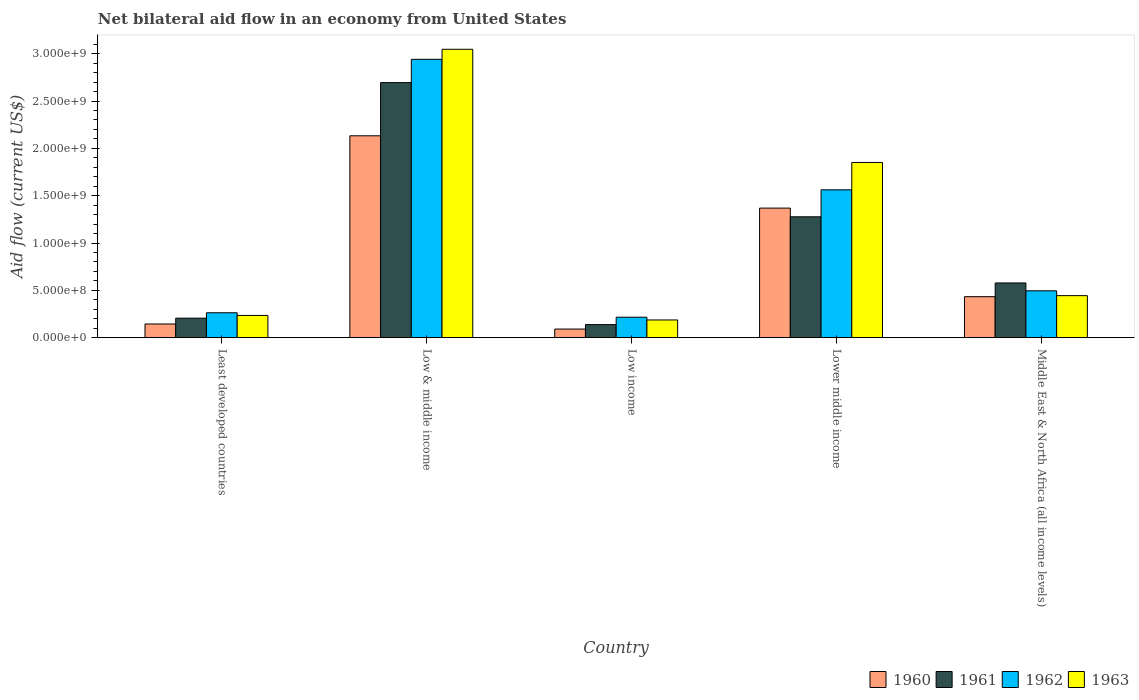How many different coloured bars are there?
Make the answer very short. 4. How many groups of bars are there?
Your answer should be very brief. 5. Are the number of bars per tick equal to the number of legend labels?
Your response must be concise. Yes. Are the number of bars on each tick of the X-axis equal?
Your answer should be very brief. Yes. How many bars are there on the 1st tick from the left?
Your answer should be compact. 4. How many bars are there on the 5th tick from the right?
Offer a terse response. 4. In how many cases, is the number of bars for a given country not equal to the number of legend labels?
Your answer should be compact. 0. What is the net bilateral aid flow in 1962 in Low & middle income?
Your response must be concise. 2.94e+09. Across all countries, what is the maximum net bilateral aid flow in 1960?
Provide a short and direct response. 2.13e+09. Across all countries, what is the minimum net bilateral aid flow in 1960?
Provide a succinct answer. 9.10e+07. In which country was the net bilateral aid flow in 1961 maximum?
Give a very brief answer. Low & middle income. In which country was the net bilateral aid flow in 1960 minimum?
Your answer should be very brief. Low income. What is the total net bilateral aid flow in 1963 in the graph?
Offer a terse response. 5.76e+09. What is the difference between the net bilateral aid flow in 1961 in Least developed countries and that in Low & middle income?
Provide a succinct answer. -2.49e+09. What is the difference between the net bilateral aid flow in 1962 in Lower middle income and the net bilateral aid flow in 1960 in Least developed countries?
Give a very brief answer. 1.42e+09. What is the average net bilateral aid flow in 1961 per country?
Your response must be concise. 9.79e+08. What is the difference between the net bilateral aid flow of/in 1963 and net bilateral aid flow of/in 1962 in Low income?
Give a very brief answer. -2.90e+07. What is the ratio of the net bilateral aid flow in 1963 in Low income to that in Middle East & North Africa (all income levels)?
Offer a terse response. 0.42. Is the net bilateral aid flow in 1962 in Low income less than that in Middle East & North Africa (all income levels)?
Ensure brevity in your answer.  Yes. Is the difference between the net bilateral aid flow in 1963 in Low & middle income and Lower middle income greater than the difference between the net bilateral aid flow in 1962 in Low & middle income and Lower middle income?
Your response must be concise. No. What is the difference between the highest and the second highest net bilateral aid flow in 1962?
Make the answer very short. 1.38e+09. What is the difference between the highest and the lowest net bilateral aid flow in 1960?
Ensure brevity in your answer.  2.04e+09. In how many countries, is the net bilateral aid flow in 1962 greater than the average net bilateral aid flow in 1962 taken over all countries?
Offer a very short reply. 2. What does the 3rd bar from the left in Low income represents?
Ensure brevity in your answer.  1962. What does the 2nd bar from the right in Low & middle income represents?
Offer a terse response. 1962. How many countries are there in the graph?
Ensure brevity in your answer.  5. Where does the legend appear in the graph?
Offer a very short reply. Bottom right. How many legend labels are there?
Give a very brief answer. 4. What is the title of the graph?
Keep it short and to the point. Net bilateral aid flow in an economy from United States. Does "1980" appear as one of the legend labels in the graph?
Make the answer very short. No. What is the label or title of the Y-axis?
Offer a very short reply. Aid flow (current US$). What is the Aid flow (current US$) in 1960 in Least developed countries?
Give a very brief answer. 1.45e+08. What is the Aid flow (current US$) in 1961 in Least developed countries?
Offer a very short reply. 2.06e+08. What is the Aid flow (current US$) of 1962 in Least developed countries?
Your answer should be very brief. 2.63e+08. What is the Aid flow (current US$) of 1963 in Least developed countries?
Ensure brevity in your answer.  2.35e+08. What is the Aid flow (current US$) of 1960 in Low & middle income?
Offer a terse response. 2.13e+09. What is the Aid flow (current US$) in 1961 in Low & middle income?
Ensure brevity in your answer.  2.70e+09. What is the Aid flow (current US$) of 1962 in Low & middle income?
Make the answer very short. 2.94e+09. What is the Aid flow (current US$) in 1963 in Low & middle income?
Make the answer very short. 3.05e+09. What is the Aid flow (current US$) in 1960 in Low income?
Provide a succinct answer. 9.10e+07. What is the Aid flow (current US$) in 1961 in Low income?
Keep it short and to the point. 1.38e+08. What is the Aid flow (current US$) in 1962 in Low income?
Provide a short and direct response. 2.16e+08. What is the Aid flow (current US$) in 1963 in Low income?
Provide a succinct answer. 1.87e+08. What is the Aid flow (current US$) of 1960 in Lower middle income?
Give a very brief answer. 1.37e+09. What is the Aid flow (current US$) in 1961 in Lower middle income?
Provide a succinct answer. 1.28e+09. What is the Aid flow (current US$) of 1962 in Lower middle income?
Offer a terse response. 1.56e+09. What is the Aid flow (current US$) of 1963 in Lower middle income?
Keep it short and to the point. 1.85e+09. What is the Aid flow (current US$) in 1960 in Middle East & North Africa (all income levels)?
Your answer should be very brief. 4.33e+08. What is the Aid flow (current US$) of 1961 in Middle East & North Africa (all income levels)?
Keep it short and to the point. 5.78e+08. What is the Aid flow (current US$) in 1962 in Middle East & North Africa (all income levels)?
Provide a short and direct response. 4.95e+08. What is the Aid flow (current US$) in 1963 in Middle East & North Africa (all income levels)?
Offer a very short reply. 4.44e+08. Across all countries, what is the maximum Aid flow (current US$) in 1960?
Your answer should be compact. 2.13e+09. Across all countries, what is the maximum Aid flow (current US$) of 1961?
Offer a terse response. 2.70e+09. Across all countries, what is the maximum Aid flow (current US$) of 1962?
Your response must be concise. 2.94e+09. Across all countries, what is the maximum Aid flow (current US$) in 1963?
Your answer should be very brief. 3.05e+09. Across all countries, what is the minimum Aid flow (current US$) of 1960?
Your answer should be compact. 9.10e+07. Across all countries, what is the minimum Aid flow (current US$) of 1961?
Provide a succinct answer. 1.38e+08. Across all countries, what is the minimum Aid flow (current US$) of 1962?
Your answer should be very brief. 2.16e+08. Across all countries, what is the minimum Aid flow (current US$) of 1963?
Offer a very short reply. 1.87e+08. What is the total Aid flow (current US$) of 1960 in the graph?
Make the answer very short. 4.17e+09. What is the total Aid flow (current US$) in 1961 in the graph?
Ensure brevity in your answer.  4.89e+09. What is the total Aid flow (current US$) of 1962 in the graph?
Provide a succinct answer. 5.48e+09. What is the total Aid flow (current US$) of 1963 in the graph?
Keep it short and to the point. 5.76e+09. What is the difference between the Aid flow (current US$) in 1960 in Least developed countries and that in Low & middle income?
Your answer should be compact. -1.99e+09. What is the difference between the Aid flow (current US$) in 1961 in Least developed countries and that in Low & middle income?
Offer a terse response. -2.49e+09. What is the difference between the Aid flow (current US$) in 1962 in Least developed countries and that in Low & middle income?
Make the answer very short. -2.68e+09. What is the difference between the Aid flow (current US$) in 1963 in Least developed countries and that in Low & middle income?
Your answer should be compact. -2.81e+09. What is the difference between the Aid flow (current US$) of 1960 in Least developed countries and that in Low income?
Provide a short and direct response. 5.35e+07. What is the difference between the Aid flow (current US$) in 1961 in Least developed countries and that in Low income?
Make the answer very short. 6.80e+07. What is the difference between the Aid flow (current US$) of 1962 in Least developed countries and that in Low income?
Give a very brief answer. 4.70e+07. What is the difference between the Aid flow (current US$) in 1963 in Least developed countries and that in Low income?
Ensure brevity in your answer.  4.80e+07. What is the difference between the Aid flow (current US$) in 1960 in Least developed countries and that in Lower middle income?
Provide a short and direct response. -1.22e+09. What is the difference between the Aid flow (current US$) in 1961 in Least developed countries and that in Lower middle income?
Give a very brief answer. -1.07e+09. What is the difference between the Aid flow (current US$) of 1962 in Least developed countries and that in Lower middle income?
Keep it short and to the point. -1.30e+09. What is the difference between the Aid flow (current US$) of 1963 in Least developed countries and that in Lower middle income?
Offer a very short reply. -1.62e+09. What is the difference between the Aid flow (current US$) of 1960 in Least developed countries and that in Middle East & North Africa (all income levels)?
Provide a succinct answer. -2.88e+08. What is the difference between the Aid flow (current US$) in 1961 in Least developed countries and that in Middle East & North Africa (all income levels)?
Your answer should be compact. -3.72e+08. What is the difference between the Aid flow (current US$) in 1962 in Least developed countries and that in Middle East & North Africa (all income levels)?
Your answer should be compact. -2.32e+08. What is the difference between the Aid flow (current US$) in 1963 in Least developed countries and that in Middle East & North Africa (all income levels)?
Make the answer very short. -2.09e+08. What is the difference between the Aid flow (current US$) in 1960 in Low & middle income and that in Low income?
Provide a short and direct response. 2.04e+09. What is the difference between the Aid flow (current US$) of 1961 in Low & middle income and that in Low income?
Offer a very short reply. 2.56e+09. What is the difference between the Aid flow (current US$) in 1962 in Low & middle income and that in Low income?
Offer a terse response. 2.72e+09. What is the difference between the Aid flow (current US$) of 1963 in Low & middle income and that in Low income?
Make the answer very short. 2.86e+09. What is the difference between the Aid flow (current US$) in 1960 in Low & middle income and that in Lower middle income?
Keep it short and to the point. 7.64e+08. What is the difference between the Aid flow (current US$) in 1961 in Low & middle income and that in Lower middle income?
Make the answer very short. 1.42e+09. What is the difference between the Aid flow (current US$) in 1962 in Low & middle income and that in Lower middle income?
Your answer should be very brief. 1.38e+09. What is the difference between the Aid flow (current US$) in 1963 in Low & middle income and that in Lower middle income?
Your response must be concise. 1.20e+09. What is the difference between the Aid flow (current US$) in 1960 in Low & middle income and that in Middle East & North Africa (all income levels)?
Provide a short and direct response. 1.70e+09. What is the difference between the Aid flow (current US$) in 1961 in Low & middle income and that in Middle East & North Africa (all income levels)?
Offer a terse response. 2.12e+09. What is the difference between the Aid flow (current US$) in 1962 in Low & middle income and that in Middle East & North Africa (all income levels)?
Your response must be concise. 2.45e+09. What is the difference between the Aid flow (current US$) of 1963 in Low & middle income and that in Middle East & North Africa (all income levels)?
Offer a very short reply. 2.60e+09. What is the difference between the Aid flow (current US$) of 1960 in Low income and that in Lower middle income?
Provide a succinct answer. -1.28e+09. What is the difference between the Aid flow (current US$) in 1961 in Low income and that in Lower middle income?
Make the answer very short. -1.14e+09. What is the difference between the Aid flow (current US$) of 1962 in Low income and that in Lower middle income?
Your answer should be compact. -1.35e+09. What is the difference between the Aid flow (current US$) of 1963 in Low income and that in Lower middle income?
Your response must be concise. -1.66e+09. What is the difference between the Aid flow (current US$) of 1960 in Low income and that in Middle East & North Africa (all income levels)?
Ensure brevity in your answer.  -3.42e+08. What is the difference between the Aid flow (current US$) of 1961 in Low income and that in Middle East & North Africa (all income levels)?
Keep it short and to the point. -4.40e+08. What is the difference between the Aid flow (current US$) of 1962 in Low income and that in Middle East & North Africa (all income levels)?
Your answer should be very brief. -2.79e+08. What is the difference between the Aid flow (current US$) of 1963 in Low income and that in Middle East & North Africa (all income levels)?
Your response must be concise. -2.57e+08. What is the difference between the Aid flow (current US$) in 1960 in Lower middle income and that in Middle East & North Africa (all income levels)?
Your response must be concise. 9.36e+08. What is the difference between the Aid flow (current US$) of 1961 in Lower middle income and that in Middle East & North Africa (all income levels)?
Your answer should be very brief. 6.99e+08. What is the difference between the Aid flow (current US$) in 1962 in Lower middle income and that in Middle East & North Africa (all income levels)?
Ensure brevity in your answer.  1.07e+09. What is the difference between the Aid flow (current US$) in 1963 in Lower middle income and that in Middle East & North Africa (all income levels)?
Provide a succinct answer. 1.41e+09. What is the difference between the Aid flow (current US$) of 1960 in Least developed countries and the Aid flow (current US$) of 1961 in Low & middle income?
Your answer should be very brief. -2.55e+09. What is the difference between the Aid flow (current US$) of 1960 in Least developed countries and the Aid flow (current US$) of 1962 in Low & middle income?
Your response must be concise. -2.80e+09. What is the difference between the Aid flow (current US$) of 1960 in Least developed countries and the Aid flow (current US$) of 1963 in Low & middle income?
Keep it short and to the point. -2.90e+09. What is the difference between the Aid flow (current US$) in 1961 in Least developed countries and the Aid flow (current US$) in 1962 in Low & middle income?
Offer a terse response. -2.74e+09. What is the difference between the Aid flow (current US$) of 1961 in Least developed countries and the Aid flow (current US$) of 1963 in Low & middle income?
Ensure brevity in your answer.  -2.84e+09. What is the difference between the Aid flow (current US$) in 1962 in Least developed countries and the Aid flow (current US$) in 1963 in Low & middle income?
Your answer should be compact. -2.78e+09. What is the difference between the Aid flow (current US$) in 1960 in Least developed countries and the Aid flow (current US$) in 1961 in Low income?
Your response must be concise. 6.52e+06. What is the difference between the Aid flow (current US$) of 1960 in Least developed countries and the Aid flow (current US$) of 1962 in Low income?
Your answer should be very brief. -7.15e+07. What is the difference between the Aid flow (current US$) of 1960 in Least developed countries and the Aid flow (current US$) of 1963 in Low income?
Offer a very short reply. -4.25e+07. What is the difference between the Aid flow (current US$) in 1961 in Least developed countries and the Aid flow (current US$) in 1962 in Low income?
Your answer should be very brief. -1.00e+07. What is the difference between the Aid flow (current US$) of 1961 in Least developed countries and the Aid flow (current US$) of 1963 in Low income?
Provide a short and direct response. 1.90e+07. What is the difference between the Aid flow (current US$) in 1962 in Least developed countries and the Aid flow (current US$) in 1963 in Low income?
Offer a terse response. 7.60e+07. What is the difference between the Aid flow (current US$) in 1960 in Least developed countries and the Aid flow (current US$) in 1961 in Lower middle income?
Your response must be concise. -1.13e+09. What is the difference between the Aid flow (current US$) in 1960 in Least developed countries and the Aid flow (current US$) in 1962 in Lower middle income?
Give a very brief answer. -1.42e+09. What is the difference between the Aid flow (current US$) of 1960 in Least developed countries and the Aid flow (current US$) of 1963 in Lower middle income?
Ensure brevity in your answer.  -1.71e+09. What is the difference between the Aid flow (current US$) of 1961 in Least developed countries and the Aid flow (current US$) of 1962 in Lower middle income?
Offer a terse response. -1.36e+09. What is the difference between the Aid flow (current US$) of 1961 in Least developed countries and the Aid flow (current US$) of 1963 in Lower middle income?
Provide a succinct answer. -1.64e+09. What is the difference between the Aid flow (current US$) in 1962 in Least developed countries and the Aid flow (current US$) in 1963 in Lower middle income?
Offer a very short reply. -1.59e+09. What is the difference between the Aid flow (current US$) in 1960 in Least developed countries and the Aid flow (current US$) in 1961 in Middle East & North Africa (all income levels)?
Give a very brief answer. -4.33e+08. What is the difference between the Aid flow (current US$) of 1960 in Least developed countries and the Aid flow (current US$) of 1962 in Middle East & North Africa (all income levels)?
Make the answer very short. -3.50e+08. What is the difference between the Aid flow (current US$) in 1960 in Least developed countries and the Aid flow (current US$) in 1963 in Middle East & North Africa (all income levels)?
Ensure brevity in your answer.  -2.99e+08. What is the difference between the Aid flow (current US$) in 1961 in Least developed countries and the Aid flow (current US$) in 1962 in Middle East & North Africa (all income levels)?
Ensure brevity in your answer.  -2.89e+08. What is the difference between the Aid flow (current US$) in 1961 in Least developed countries and the Aid flow (current US$) in 1963 in Middle East & North Africa (all income levels)?
Make the answer very short. -2.38e+08. What is the difference between the Aid flow (current US$) of 1962 in Least developed countries and the Aid flow (current US$) of 1963 in Middle East & North Africa (all income levels)?
Your response must be concise. -1.81e+08. What is the difference between the Aid flow (current US$) of 1960 in Low & middle income and the Aid flow (current US$) of 1961 in Low income?
Give a very brief answer. 2.00e+09. What is the difference between the Aid flow (current US$) in 1960 in Low & middle income and the Aid flow (current US$) in 1962 in Low income?
Your answer should be compact. 1.92e+09. What is the difference between the Aid flow (current US$) of 1960 in Low & middle income and the Aid flow (current US$) of 1963 in Low income?
Offer a terse response. 1.95e+09. What is the difference between the Aid flow (current US$) of 1961 in Low & middle income and the Aid flow (current US$) of 1962 in Low income?
Provide a succinct answer. 2.48e+09. What is the difference between the Aid flow (current US$) of 1961 in Low & middle income and the Aid flow (current US$) of 1963 in Low income?
Give a very brief answer. 2.51e+09. What is the difference between the Aid flow (current US$) in 1962 in Low & middle income and the Aid flow (current US$) in 1963 in Low income?
Keep it short and to the point. 2.75e+09. What is the difference between the Aid flow (current US$) in 1960 in Low & middle income and the Aid flow (current US$) in 1961 in Lower middle income?
Your answer should be compact. 8.56e+08. What is the difference between the Aid flow (current US$) in 1960 in Low & middle income and the Aid flow (current US$) in 1962 in Lower middle income?
Your answer should be very brief. 5.71e+08. What is the difference between the Aid flow (current US$) of 1960 in Low & middle income and the Aid flow (current US$) of 1963 in Lower middle income?
Offer a very short reply. 2.82e+08. What is the difference between the Aid flow (current US$) of 1961 in Low & middle income and the Aid flow (current US$) of 1962 in Lower middle income?
Offer a terse response. 1.13e+09. What is the difference between the Aid flow (current US$) in 1961 in Low & middle income and the Aid flow (current US$) in 1963 in Lower middle income?
Your answer should be compact. 8.44e+08. What is the difference between the Aid flow (current US$) in 1962 in Low & middle income and the Aid flow (current US$) in 1963 in Lower middle income?
Offer a very short reply. 1.09e+09. What is the difference between the Aid flow (current US$) in 1960 in Low & middle income and the Aid flow (current US$) in 1961 in Middle East & North Africa (all income levels)?
Your response must be concise. 1.56e+09. What is the difference between the Aid flow (current US$) in 1960 in Low & middle income and the Aid flow (current US$) in 1962 in Middle East & North Africa (all income levels)?
Your response must be concise. 1.64e+09. What is the difference between the Aid flow (current US$) of 1960 in Low & middle income and the Aid flow (current US$) of 1963 in Middle East & North Africa (all income levels)?
Make the answer very short. 1.69e+09. What is the difference between the Aid flow (current US$) in 1961 in Low & middle income and the Aid flow (current US$) in 1962 in Middle East & North Africa (all income levels)?
Ensure brevity in your answer.  2.20e+09. What is the difference between the Aid flow (current US$) in 1961 in Low & middle income and the Aid flow (current US$) in 1963 in Middle East & North Africa (all income levels)?
Provide a succinct answer. 2.25e+09. What is the difference between the Aid flow (current US$) in 1962 in Low & middle income and the Aid flow (current US$) in 1963 in Middle East & North Africa (all income levels)?
Offer a terse response. 2.50e+09. What is the difference between the Aid flow (current US$) of 1960 in Low income and the Aid flow (current US$) of 1961 in Lower middle income?
Your answer should be very brief. -1.19e+09. What is the difference between the Aid flow (current US$) in 1960 in Low income and the Aid flow (current US$) in 1962 in Lower middle income?
Provide a short and direct response. -1.47e+09. What is the difference between the Aid flow (current US$) in 1960 in Low income and the Aid flow (current US$) in 1963 in Lower middle income?
Make the answer very short. -1.76e+09. What is the difference between the Aid flow (current US$) in 1961 in Low income and the Aid flow (current US$) in 1962 in Lower middle income?
Keep it short and to the point. -1.42e+09. What is the difference between the Aid flow (current US$) in 1961 in Low income and the Aid flow (current US$) in 1963 in Lower middle income?
Ensure brevity in your answer.  -1.71e+09. What is the difference between the Aid flow (current US$) in 1962 in Low income and the Aid flow (current US$) in 1963 in Lower middle income?
Your answer should be compact. -1.64e+09. What is the difference between the Aid flow (current US$) of 1960 in Low income and the Aid flow (current US$) of 1961 in Middle East & North Africa (all income levels)?
Ensure brevity in your answer.  -4.87e+08. What is the difference between the Aid flow (current US$) of 1960 in Low income and the Aid flow (current US$) of 1962 in Middle East & North Africa (all income levels)?
Provide a succinct answer. -4.04e+08. What is the difference between the Aid flow (current US$) in 1960 in Low income and the Aid flow (current US$) in 1963 in Middle East & North Africa (all income levels)?
Offer a terse response. -3.53e+08. What is the difference between the Aid flow (current US$) of 1961 in Low income and the Aid flow (current US$) of 1962 in Middle East & North Africa (all income levels)?
Provide a succinct answer. -3.57e+08. What is the difference between the Aid flow (current US$) in 1961 in Low income and the Aid flow (current US$) in 1963 in Middle East & North Africa (all income levels)?
Your response must be concise. -3.06e+08. What is the difference between the Aid flow (current US$) in 1962 in Low income and the Aid flow (current US$) in 1963 in Middle East & North Africa (all income levels)?
Offer a terse response. -2.28e+08. What is the difference between the Aid flow (current US$) in 1960 in Lower middle income and the Aid flow (current US$) in 1961 in Middle East & North Africa (all income levels)?
Your answer should be compact. 7.91e+08. What is the difference between the Aid flow (current US$) in 1960 in Lower middle income and the Aid flow (current US$) in 1962 in Middle East & North Africa (all income levels)?
Offer a very short reply. 8.74e+08. What is the difference between the Aid flow (current US$) of 1960 in Lower middle income and the Aid flow (current US$) of 1963 in Middle East & North Africa (all income levels)?
Make the answer very short. 9.25e+08. What is the difference between the Aid flow (current US$) in 1961 in Lower middle income and the Aid flow (current US$) in 1962 in Middle East & North Africa (all income levels)?
Provide a succinct answer. 7.82e+08. What is the difference between the Aid flow (current US$) of 1961 in Lower middle income and the Aid flow (current US$) of 1963 in Middle East & North Africa (all income levels)?
Your answer should be very brief. 8.33e+08. What is the difference between the Aid flow (current US$) of 1962 in Lower middle income and the Aid flow (current US$) of 1963 in Middle East & North Africa (all income levels)?
Your response must be concise. 1.12e+09. What is the average Aid flow (current US$) of 1960 per country?
Your response must be concise. 8.34e+08. What is the average Aid flow (current US$) in 1961 per country?
Give a very brief answer. 9.79e+08. What is the average Aid flow (current US$) of 1962 per country?
Keep it short and to the point. 1.10e+09. What is the average Aid flow (current US$) in 1963 per country?
Your answer should be very brief. 1.15e+09. What is the difference between the Aid flow (current US$) in 1960 and Aid flow (current US$) in 1961 in Least developed countries?
Your answer should be very brief. -6.15e+07. What is the difference between the Aid flow (current US$) in 1960 and Aid flow (current US$) in 1962 in Least developed countries?
Give a very brief answer. -1.18e+08. What is the difference between the Aid flow (current US$) in 1960 and Aid flow (current US$) in 1963 in Least developed countries?
Make the answer very short. -9.05e+07. What is the difference between the Aid flow (current US$) of 1961 and Aid flow (current US$) of 1962 in Least developed countries?
Offer a very short reply. -5.70e+07. What is the difference between the Aid flow (current US$) of 1961 and Aid flow (current US$) of 1963 in Least developed countries?
Your answer should be very brief. -2.90e+07. What is the difference between the Aid flow (current US$) of 1962 and Aid flow (current US$) of 1963 in Least developed countries?
Your response must be concise. 2.80e+07. What is the difference between the Aid flow (current US$) in 1960 and Aid flow (current US$) in 1961 in Low & middle income?
Your answer should be compact. -5.62e+08. What is the difference between the Aid flow (current US$) of 1960 and Aid flow (current US$) of 1962 in Low & middle income?
Offer a terse response. -8.08e+08. What is the difference between the Aid flow (current US$) in 1960 and Aid flow (current US$) in 1963 in Low & middle income?
Offer a very short reply. -9.14e+08. What is the difference between the Aid flow (current US$) of 1961 and Aid flow (current US$) of 1962 in Low & middle income?
Provide a short and direct response. -2.46e+08. What is the difference between the Aid flow (current US$) of 1961 and Aid flow (current US$) of 1963 in Low & middle income?
Make the answer very short. -3.52e+08. What is the difference between the Aid flow (current US$) in 1962 and Aid flow (current US$) in 1963 in Low & middle income?
Provide a succinct answer. -1.06e+08. What is the difference between the Aid flow (current US$) in 1960 and Aid flow (current US$) in 1961 in Low income?
Your answer should be very brief. -4.70e+07. What is the difference between the Aid flow (current US$) in 1960 and Aid flow (current US$) in 1962 in Low income?
Ensure brevity in your answer.  -1.25e+08. What is the difference between the Aid flow (current US$) in 1960 and Aid flow (current US$) in 1963 in Low income?
Offer a very short reply. -9.60e+07. What is the difference between the Aid flow (current US$) of 1961 and Aid flow (current US$) of 1962 in Low income?
Give a very brief answer. -7.80e+07. What is the difference between the Aid flow (current US$) of 1961 and Aid flow (current US$) of 1963 in Low income?
Keep it short and to the point. -4.90e+07. What is the difference between the Aid flow (current US$) of 1962 and Aid flow (current US$) of 1963 in Low income?
Offer a terse response. 2.90e+07. What is the difference between the Aid flow (current US$) in 1960 and Aid flow (current US$) in 1961 in Lower middle income?
Provide a short and direct response. 9.20e+07. What is the difference between the Aid flow (current US$) in 1960 and Aid flow (current US$) in 1962 in Lower middle income?
Provide a short and direct response. -1.93e+08. What is the difference between the Aid flow (current US$) of 1960 and Aid flow (current US$) of 1963 in Lower middle income?
Keep it short and to the point. -4.82e+08. What is the difference between the Aid flow (current US$) of 1961 and Aid flow (current US$) of 1962 in Lower middle income?
Ensure brevity in your answer.  -2.85e+08. What is the difference between the Aid flow (current US$) in 1961 and Aid flow (current US$) in 1963 in Lower middle income?
Offer a very short reply. -5.74e+08. What is the difference between the Aid flow (current US$) of 1962 and Aid flow (current US$) of 1963 in Lower middle income?
Offer a very short reply. -2.89e+08. What is the difference between the Aid flow (current US$) in 1960 and Aid flow (current US$) in 1961 in Middle East & North Africa (all income levels)?
Offer a terse response. -1.45e+08. What is the difference between the Aid flow (current US$) of 1960 and Aid flow (current US$) of 1962 in Middle East & North Africa (all income levels)?
Your answer should be very brief. -6.20e+07. What is the difference between the Aid flow (current US$) of 1960 and Aid flow (current US$) of 1963 in Middle East & North Africa (all income levels)?
Offer a terse response. -1.10e+07. What is the difference between the Aid flow (current US$) in 1961 and Aid flow (current US$) in 1962 in Middle East & North Africa (all income levels)?
Give a very brief answer. 8.30e+07. What is the difference between the Aid flow (current US$) in 1961 and Aid flow (current US$) in 1963 in Middle East & North Africa (all income levels)?
Keep it short and to the point. 1.34e+08. What is the difference between the Aid flow (current US$) in 1962 and Aid flow (current US$) in 1963 in Middle East & North Africa (all income levels)?
Keep it short and to the point. 5.10e+07. What is the ratio of the Aid flow (current US$) of 1960 in Least developed countries to that in Low & middle income?
Ensure brevity in your answer.  0.07. What is the ratio of the Aid flow (current US$) in 1961 in Least developed countries to that in Low & middle income?
Offer a terse response. 0.08. What is the ratio of the Aid flow (current US$) of 1962 in Least developed countries to that in Low & middle income?
Your answer should be very brief. 0.09. What is the ratio of the Aid flow (current US$) of 1963 in Least developed countries to that in Low & middle income?
Provide a short and direct response. 0.08. What is the ratio of the Aid flow (current US$) in 1960 in Least developed countries to that in Low income?
Offer a terse response. 1.59. What is the ratio of the Aid flow (current US$) of 1961 in Least developed countries to that in Low income?
Your answer should be very brief. 1.49. What is the ratio of the Aid flow (current US$) in 1962 in Least developed countries to that in Low income?
Offer a very short reply. 1.22. What is the ratio of the Aid flow (current US$) in 1963 in Least developed countries to that in Low income?
Your answer should be very brief. 1.26. What is the ratio of the Aid flow (current US$) of 1960 in Least developed countries to that in Lower middle income?
Offer a very short reply. 0.11. What is the ratio of the Aid flow (current US$) in 1961 in Least developed countries to that in Lower middle income?
Offer a very short reply. 0.16. What is the ratio of the Aid flow (current US$) of 1962 in Least developed countries to that in Lower middle income?
Make the answer very short. 0.17. What is the ratio of the Aid flow (current US$) of 1963 in Least developed countries to that in Lower middle income?
Give a very brief answer. 0.13. What is the ratio of the Aid flow (current US$) of 1960 in Least developed countries to that in Middle East & North Africa (all income levels)?
Provide a short and direct response. 0.33. What is the ratio of the Aid flow (current US$) of 1961 in Least developed countries to that in Middle East & North Africa (all income levels)?
Offer a very short reply. 0.36. What is the ratio of the Aid flow (current US$) of 1962 in Least developed countries to that in Middle East & North Africa (all income levels)?
Your answer should be very brief. 0.53. What is the ratio of the Aid flow (current US$) of 1963 in Least developed countries to that in Middle East & North Africa (all income levels)?
Provide a short and direct response. 0.53. What is the ratio of the Aid flow (current US$) in 1960 in Low & middle income to that in Low income?
Your response must be concise. 23.44. What is the ratio of the Aid flow (current US$) of 1961 in Low & middle income to that in Low income?
Offer a terse response. 19.53. What is the ratio of the Aid flow (current US$) of 1962 in Low & middle income to that in Low income?
Your answer should be compact. 13.62. What is the ratio of the Aid flow (current US$) of 1963 in Low & middle income to that in Low income?
Your response must be concise. 16.29. What is the ratio of the Aid flow (current US$) of 1960 in Low & middle income to that in Lower middle income?
Provide a succinct answer. 1.56. What is the ratio of the Aid flow (current US$) in 1961 in Low & middle income to that in Lower middle income?
Give a very brief answer. 2.11. What is the ratio of the Aid flow (current US$) of 1962 in Low & middle income to that in Lower middle income?
Your answer should be compact. 1.88. What is the ratio of the Aid flow (current US$) of 1963 in Low & middle income to that in Lower middle income?
Offer a very short reply. 1.65. What is the ratio of the Aid flow (current US$) of 1960 in Low & middle income to that in Middle East & North Africa (all income levels)?
Ensure brevity in your answer.  4.93. What is the ratio of the Aid flow (current US$) of 1961 in Low & middle income to that in Middle East & North Africa (all income levels)?
Offer a terse response. 4.66. What is the ratio of the Aid flow (current US$) of 1962 in Low & middle income to that in Middle East & North Africa (all income levels)?
Your answer should be compact. 5.94. What is the ratio of the Aid flow (current US$) in 1963 in Low & middle income to that in Middle East & North Africa (all income levels)?
Your answer should be very brief. 6.86. What is the ratio of the Aid flow (current US$) in 1960 in Low income to that in Lower middle income?
Your answer should be very brief. 0.07. What is the ratio of the Aid flow (current US$) of 1961 in Low income to that in Lower middle income?
Make the answer very short. 0.11. What is the ratio of the Aid flow (current US$) of 1962 in Low income to that in Lower middle income?
Offer a very short reply. 0.14. What is the ratio of the Aid flow (current US$) in 1963 in Low income to that in Lower middle income?
Your answer should be compact. 0.1. What is the ratio of the Aid flow (current US$) in 1960 in Low income to that in Middle East & North Africa (all income levels)?
Make the answer very short. 0.21. What is the ratio of the Aid flow (current US$) of 1961 in Low income to that in Middle East & North Africa (all income levels)?
Provide a short and direct response. 0.24. What is the ratio of the Aid flow (current US$) in 1962 in Low income to that in Middle East & North Africa (all income levels)?
Provide a short and direct response. 0.44. What is the ratio of the Aid flow (current US$) of 1963 in Low income to that in Middle East & North Africa (all income levels)?
Give a very brief answer. 0.42. What is the ratio of the Aid flow (current US$) of 1960 in Lower middle income to that in Middle East & North Africa (all income levels)?
Offer a very short reply. 3.16. What is the ratio of the Aid flow (current US$) of 1961 in Lower middle income to that in Middle East & North Africa (all income levels)?
Give a very brief answer. 2.21. What is the ratio of the Aid flow (current US$) of 1962 in Lower middle income to that in Middle East & North Africa (all income levels)?
Provide a short and direct response. 3.16. What is the ratio of the Aid flow (current US$) in 1963 in Lower middle income to that in Middle East & North Africa (all income levels)?
Your response must be concise. 4.17. What is the difference between the highest and the second highest Aid flow (current US$) of 1960?
Provide a succinct answer. 7.64e+08. What is the difference between the highest and the second highest Aid flow (current US$) of 1961?
Provide a short and direct response. 1.42e+09. What is the difference between the highest and the second highest Aid flow (current US$) in 1962?
Your answer should be compact. 1.38e+09. What is the difference between the highest and the second highest Aid flow (current US$) in 1963?
Your response must be concise. 1.20e+09. What is the difference between the highest and the lowest Aid flow (current US$) in 1960?
Provide a short and direct response. 2.04e+09. What is the difference between the highest and the lowest Aid flow (current US$) in 1961?
Your response must be concise. 2.56e+09. What is the difference between the highest and the lowest Aid flow (current US$) in 1962?
Provide a succinct answer. 2.72e+09. What is the difference between the highest and the lowest Aid flow (current US$) of 1963?
Your answer should be compact. 2.86e+09. 